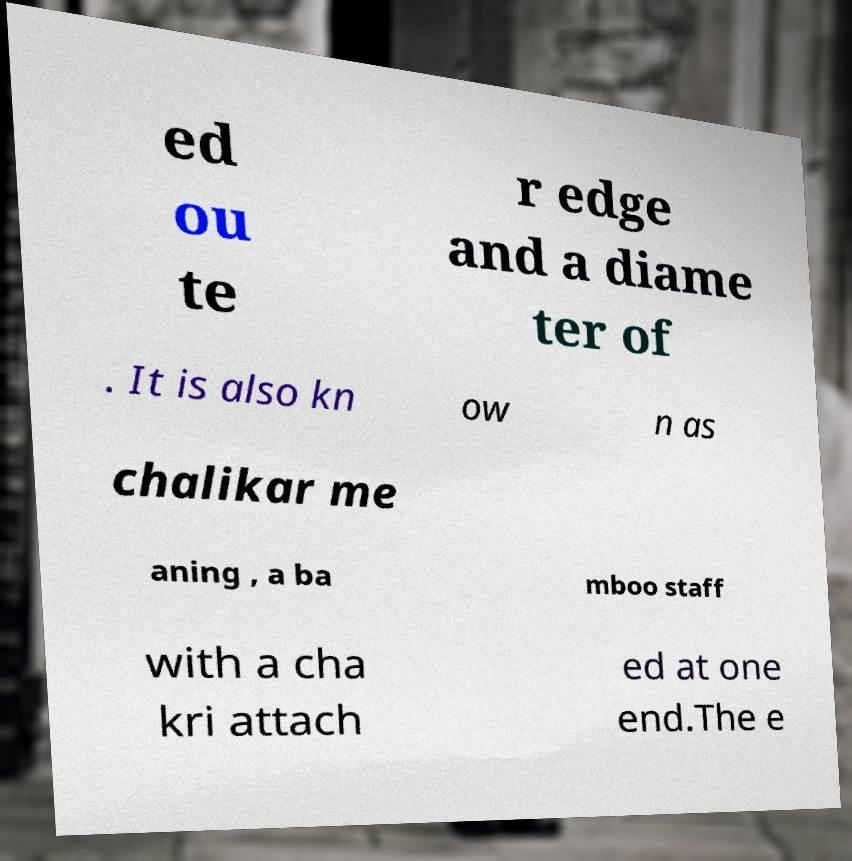For documentation purposes, I need the text within this image transcribed. Could you provide that? ed ou te r edge and a diame ter of . It is also kn ow n as chalikar me aning , a ba mboo staff with a cha kri attach ed at one end.The e 